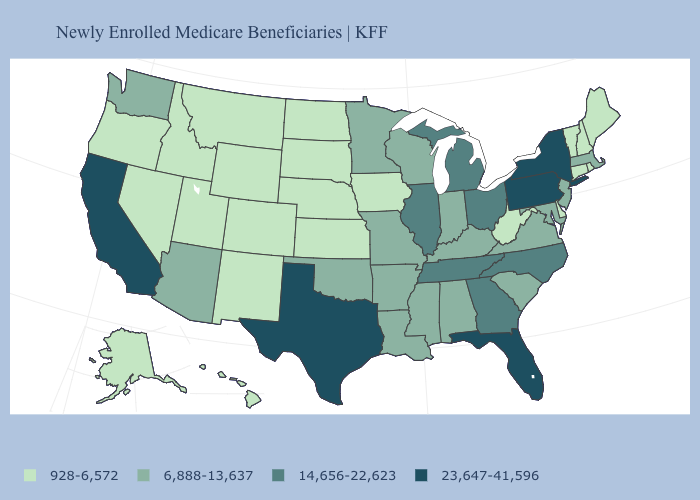Name the states that have a value in the range 6,888-13,637?
Write a very short answer. Alabama, Arizona, Arkansas, Indiana, Kentucky, Louisiana, Maryland, Massachusetts, Minnesota, Mississippi, Missouri, New Jersey, Oklahoma, South Carolina, Virginia, Washington, Wisconsin. Does Oregon have the highest value in the West?
Concise answer only. No. Name the states that have a value in the range 928-6,572?
Answer briefly. Alaska, Colorado, Connecticut, Delaware, Hawaii, Idaho, Iowa, Kansas, Maine, Montana, Nebraska, Nevada, New Hampshire, New Mexico, North Dakota, Oregon, Rhode Island, South Dakota, Utah, Vermont, West Virginia, Wyoming. Does New York have the highest value in the USA?
Keep it brief. Yes. What is the lowest value in the MidWest?
Give a very brief answer. 928-6,572. Among the states that border South Carolina , which have the highest value?
Be succinct. Georgia, North Carolina. Name the states that have a value in the range 23,647-41,596?
Write a very short answer. California, Florida, New York, Pennsylvania, Texas. What is the highest value in the USA?
Concise answer only. 23,647-41,596. Does Tennessee have a lower value than New Mexico?
Write a very short answer. No. Does New Hampshire have the lowest value in the USA?
Short answer required. Yes. Does the map have missing data?
Quick response, please. No. Name the states that have a value in the range 6,888-13,637?
Give a very brief answer. Alabama, Arizona, Arkansas, Indiana, Kentucky, Louisiana, Maryland, Massachusetts, Minnesota, Mississippi, Missouri, New Jersey, Oklahoma, South Carolina, Virginia, Washington, Wisconsin. What is the value of Texas?
Answer briefly. 23,647-41,596. Does the first symbol in the legend represent the smallest category?
Concise answer only. Yes. Does the first symbol in the legend represent the smallest category?
Quick response, please. Yes. 